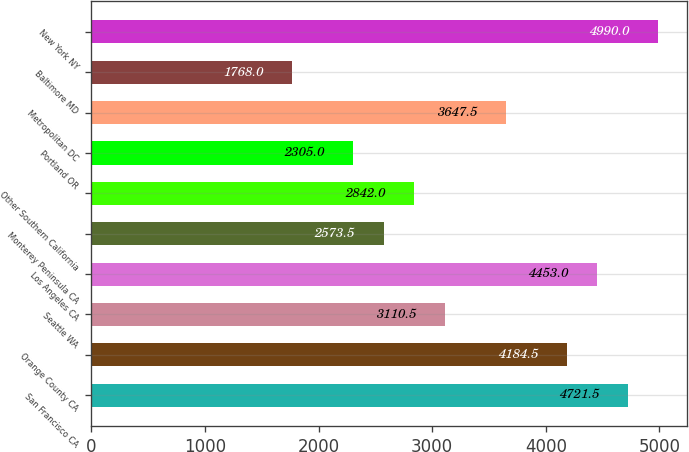<chart> <loc_0><loc_0><loc_500><loc_500><bar_chart><fcel>San Francisco CA<fcel>Orange County CA<fcel>Seattle WA<fcel>Los Angeles CA<fcel>Monterey Peninsula CA<fcel>Other Southern California<fcel>Portland OR<fcel>Metropolitan DC<fcel>Baltimore MD<fcel>New York NY<nl><fcel>4721.5<fcel>4184.5<fcel>3110.5<fcel>4453<fcel>2573.5<fcel>2842<fcel>2305<fcel>3647.5<fcel>1768<fcel>4990<nl></chart> 